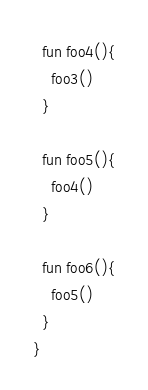<code> <loc_0><loc_0><loc_500><loc_500><_Kotlin_>
  fun foo4(){
    foo3()
  }

  fun foo5(){
    foo4()
  }

  fun foo6(){
    foo5()
  }
}</code> 